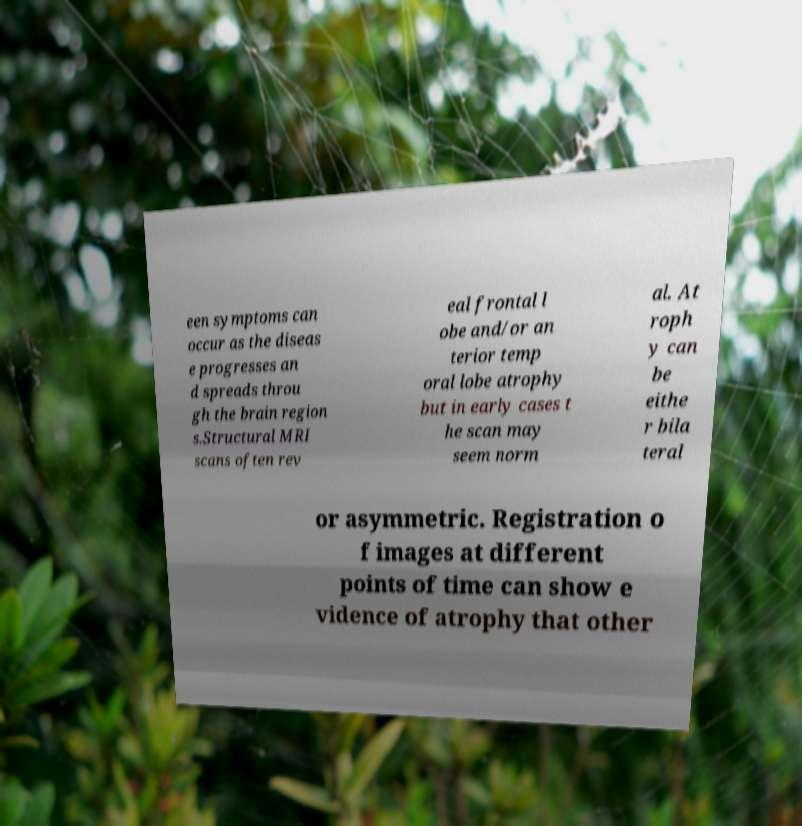Could you extract and type out the text from this image? een symptoms can occur as the diseas e progresses an d spreads throu gh the brain region s.Structural MRI scans often rev eal frontal l obe and/or an terior temp oral lobe atrophy but in early cases t he scan may seem norm al. At roph y can be eithe r bila teral or asymmetric. Registration o f images at different points of time can show e vidence of atrophy that other 